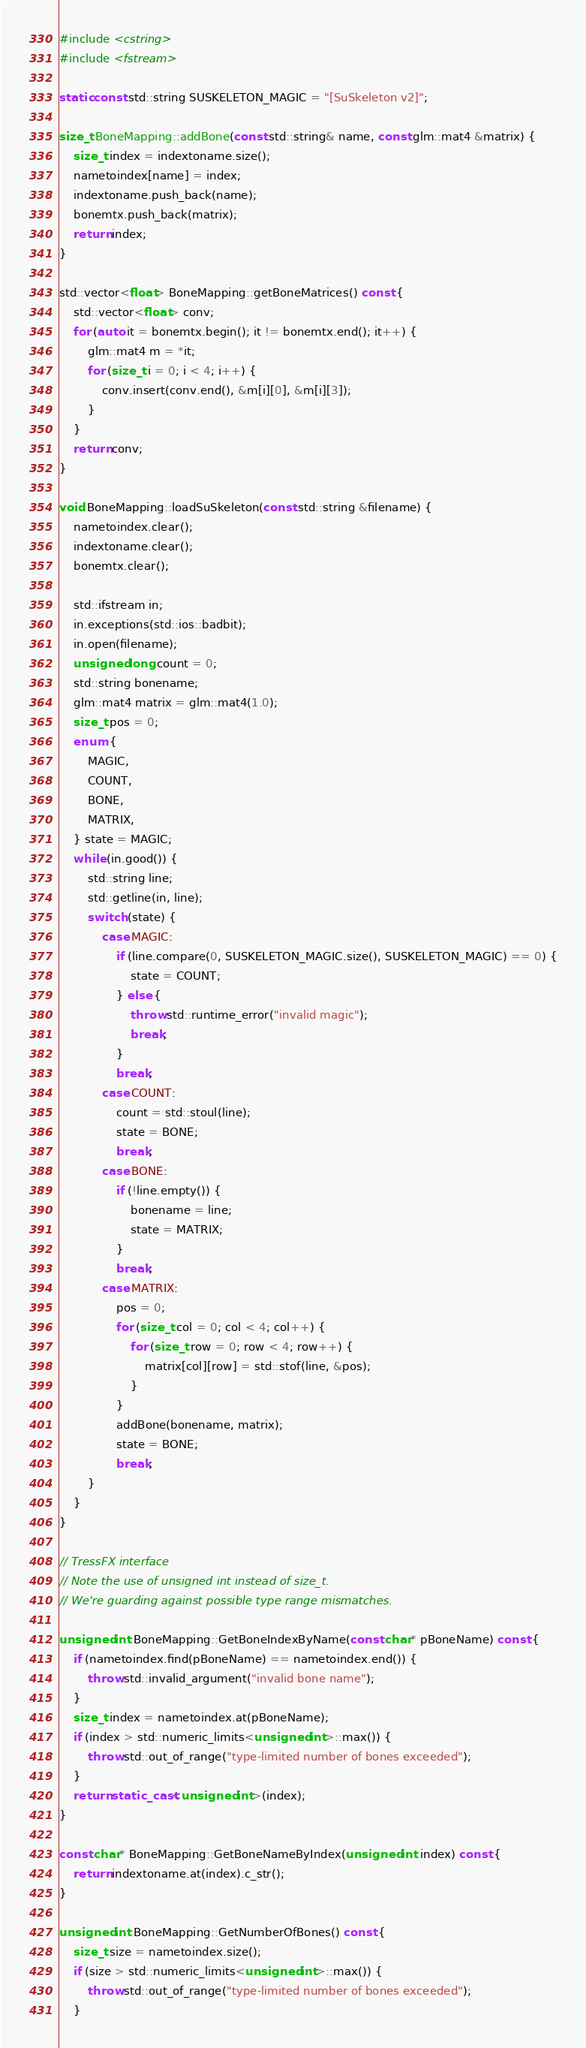Convert code to text. <code><loc_0><loc_0><loc_500><loc_500><_C++_>#include <cstring>
#include <fstream>

static const std::string SUSKELETON_MAGIC = "[SuSkeleton v2]";

size_t BoneMapping::addBone(const std::string& name, const glm::mat4 &matrix) {
	size_t index = indextoname.size();
	nametoindex[name] = index;
	indextoname.push_back(name);
	bonemtx.push_back(matrix);
	return index;
}

std::vector<float> BoneMapping::getBoneMatrices() const {
	std::vector<float> conv;
	for (auto it = bonemtx.begin(); it != bonemtx.end(); it++) {
		glm::mat4 m = *it;
		for (size_t i = 0; i < 4; i++) {
			conv.insert(conv.end(), &m[i][0], &m[i][3]);
		}
	}
	return conv;
}

void BoneMapping::loadSuSkeleton(const std::string &filename) {
	nametoindex.clear();
	indextoname.clear();
	bonemtx.clear();

	std::ifstream in;
	in.exceptions(std::ios::badbit);
	in.open(filename);
	unsigned long count = 0;
	std::string bonename;
	glm::mat4 matrix = glm::mat4(1.0);
	size_t pos = 0;
	enum {
		MAGIC,
		COUNT,
		BONE,
		MATRIX,
	} state = MAGIC;
	while (in.good()) {
		std::string line;
		std::getline(in, line);
		switch (state) {
			case MAGIC:
				if (line.compare(0, SUSKELETON_MAGIC.size(), SUSKELETON_MAGIC) == 0) {
					state = COUNT;
				} else {
					throw std::runtime_error("invalid magic");
					break;
				}
				break;
			case COUNT:
				count = std::stoul(line);
				state = BONE;
				break;
			case BONE:
				if (!line.empty()) {
					bonename = line;
					state = MATRIX;
				}
				break;
			case MATRIX:
				pos = 0;
				for (size_t col = 0; col < 4; col++) {
					for (size_t row = 0; row < 4; row++) {
						matrix[col][row] = std::stof(line, &pos);
					}
				}
				addBone(bonename, matrix);
				state = BONE;
				break;
		}
	}
}

// TressFX interface
// Note the use of unsigned int instead of size_t.
// We're guarding against possible type range mismatches.

unsigned int BoneMapping::GetBoneIndexByName(const char* pBoneName) const {
	if (nametoindex.find(pBoneName) == nametoindex.end()) {
		throw std::invalid_argument("invalid bone name");
	}
	size_t index = nametoindex.at(pBoneName);
	if (index > std::numeric_limits<unsigned int>::max()) {
		throw std::out_of_range("type-limited number of bones exceeded");
	}
	return static_cast<unsigned int>(index);
}

const char* BoneMapping::GetBoneNameByIndex(unsigned int index) const {
	return indextoname.at(index).c_str();
}

unsigned int BoneMapping::GetNumberOfBones() const {
	size_t size = nametoindex.size();
	if (size > std::numeric_limits<unsigned int>::max()) {
		throw std::out_of_range("type-limited number of bones exceeded");
	}</code> 